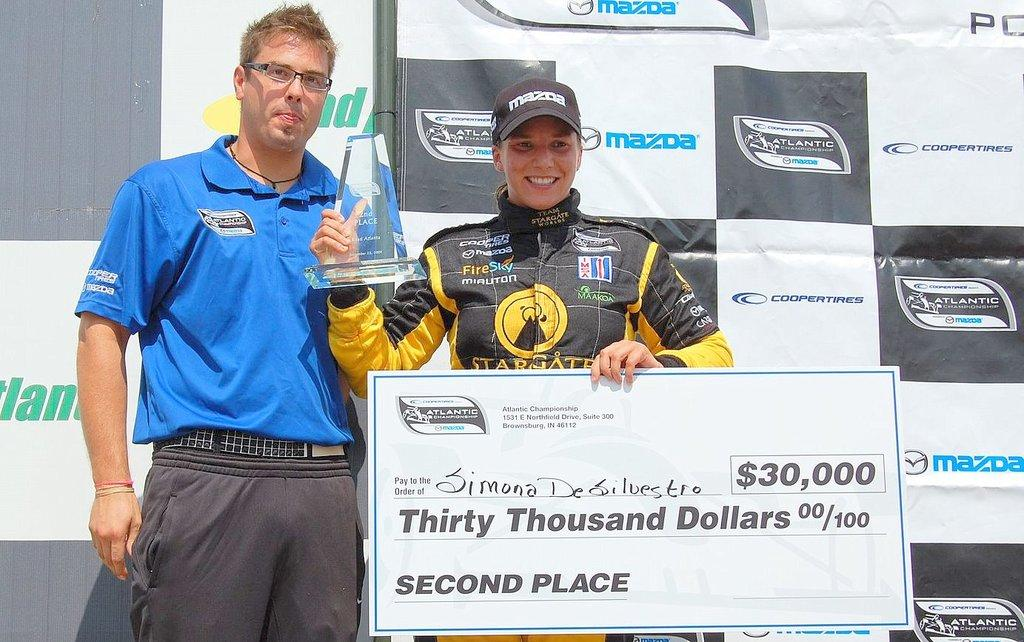<image>
Summarize the visual content of the image. A check is made out for thirty thousand dollars. 